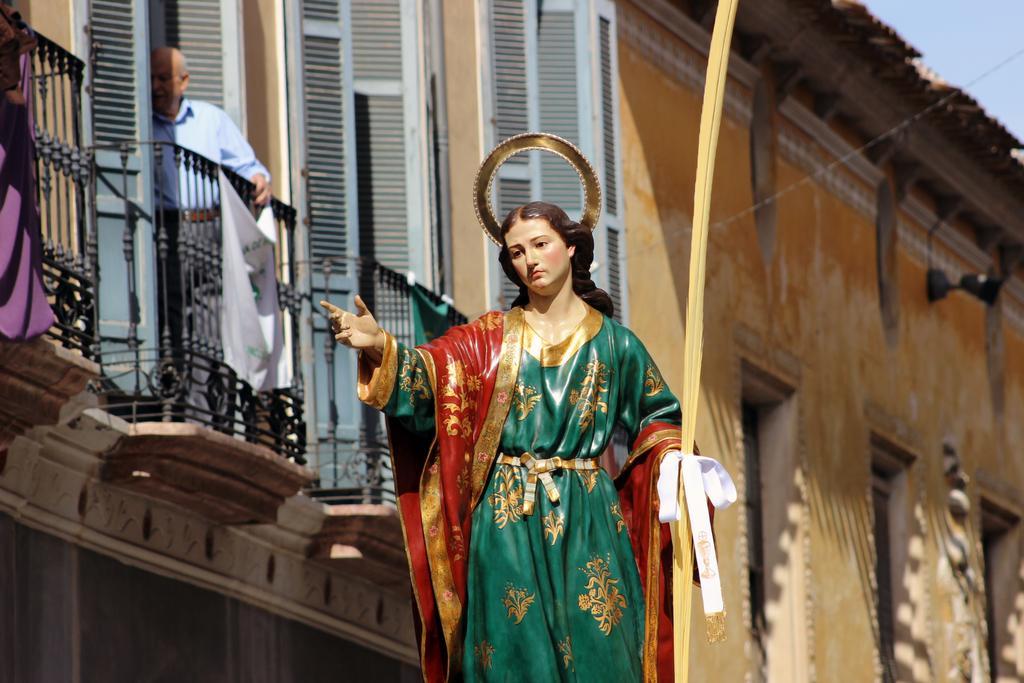Please provide a concise description of this image. Here I can see a statue of a person. In the background there is a building. On the left side there is a man standing behind the railing. In the top right, I can see the sky. 